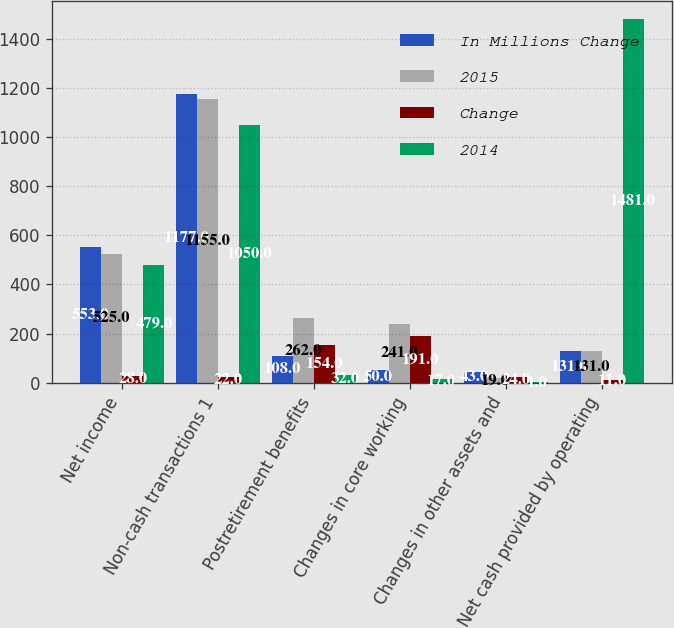Convert chart. <chart><loc_0><loc_0><loc_500><loc_500><stacked_bar_chart><ecel><fcel>Net income<fcel>Non-cash transactions 1<fcel>Postretirement benefits<fcel>Changes in core working<fcel>Changes in other assets and<fcel>Net cash provided by operating<nl><fcel>In Millions Change<fcel>553<fcel>1177<fcel>108<fcel>50<fcel>43<fcel>131<nl><fcel>2015<fcel>525<fcel>1155<fcel>262<fcel>241<fcel>19<fcel>131<nl><fcel>Change<fcel>28<fcel>22<fcel>154<fcel>191<fcel>24<fcel>11<nl><fcel>2014<fcel>479<fcel>1050<fcel>32<fcel>17<fcel>1<fcel>1481<nl></chart> 